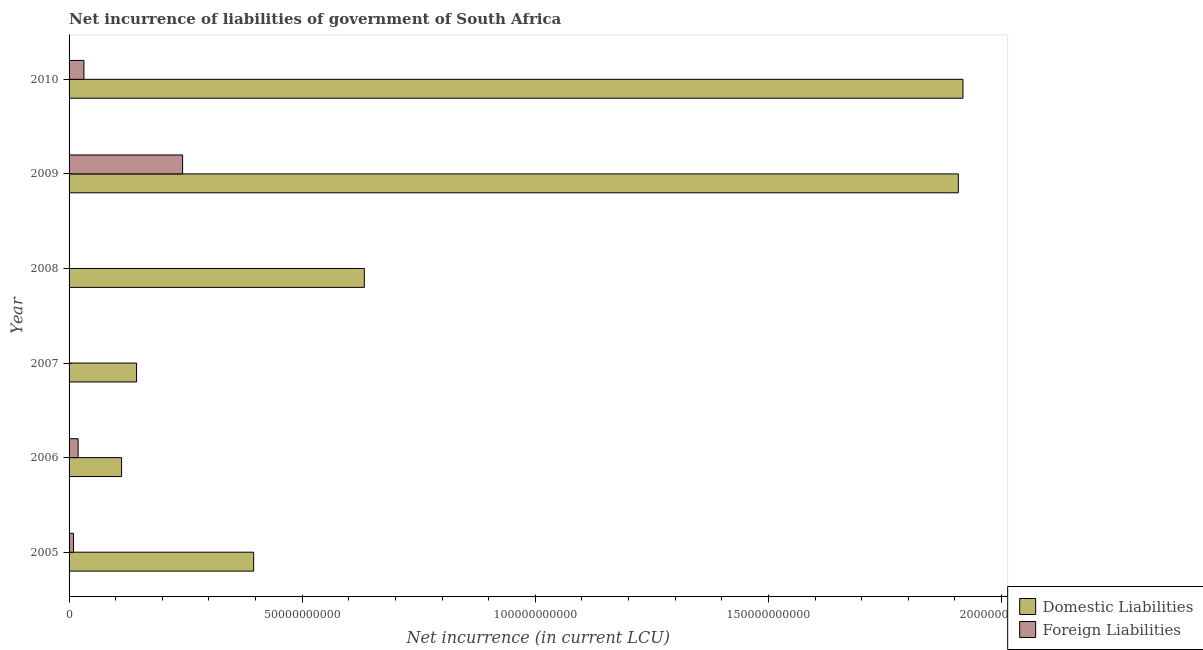How many different coloured bars are there?
Keep it short and to the point. 2. Are the number of bars per tick equal to the number of legend labels?
Your answer should be compact. No. Are the number of bars on each tick of the Y-axis equal?
Give a very brief answer. No. What is the label of the 4th group of bars from the top?
Your answer should be very brief. 2007. In how many cases, is the number of bars for a given year not equal to the number of legend labels?
Make the answer very short. 2. What is the net incurrence of foreign liabilities in 2006?
Make the answer very short. 1.94e+09. Across all years, what is the maximum net incurrence of domestic liabilities?
Make the answer very short. 1.92e+11. Across all years, what is the minimum net incurrence of domestic liabilities?
Ensure brevity in your answer.  1.13e+1. What is the total net incurrence of domestic liabilities in the graph?
Ensure brevity in your answer.  5.11e+11. What is the difference between the net incurrence of domestic liabilities in 2006 and that in 2007?
Your response must be concise. -3.21e+09. What is the difference between the net incurrence of foreign liabilities in 2009 and the net incurrence of domestic liabilities in 2010?
Ensure brevity in your answer.  -1.67e+11. What is the average net incurrence of foreign liabilities per year?
Offer a terse response. 5.07e+09. In the year 2009, what is the difference between the net incurrence of foreign liabilities and net incurrence of domestic liabilities?
Provide a short and direct response. -1.66e+11. In how many years, is the net incurrence of domestic liabilities greater than 10000000000 LCU?
Provide a succinct answer. 6. What is the ratio of the net incurrence of foreign liabilities in 2005 to that in 2010?
Keep it short and to the point. 0.3. Is the net incurrence of foreign liabilities in 2005 less than that in 2010?
Offer a terse response. Yes. Is the difference between the net incurrence of foreign liabilities in 2005 and 2006 greater than the difference between the net incurrence of domestic liabilities in 2005 and 2006?
Your response must be concise. No. What is the difference between the highest and the second highest net incurrence of foreign liabilities?
Your answer should be compact. 2.12e+1. What is the difference between the highest and the lowest net incurrence of foreign liabilities?
Keep it short and to the point. 2.44e+1. How many bars are there?
Offer a very short reply. 10. Are all the bars in the graph horizontal?
Make the answer very short. Yes. What is the difference between two consecutive major ticks on the X-axis?
Your response must be concise. 5.00e+1. Does the graph contain grids?
Offer a very short reply. No. How many legend labels are there?
Offer a very short reply. 2. What is the title of the graph?
Ensure brevity in your answer.  Net incurrence of liabilities of government of South Africa. Does "Infant" appear as one of the legend labels in the graph?
Your answer should be very brief. No. What is the label or title of the X-axis?
Offer a terse response. Net incurrence (in current LCU). What is the label or title of the Y-axis?
Your response must be concise. Year. What is the Net incurrence (in current LCU) in Domestic Liabilities in 2005?
Keep it short and to the point. 3.96e+1. What is the Net incurrence (in current LCU) of Foreign Liabilities in 2005?
Offer a very short reply. 9.50e+08. What is the Net incurrence (in current LCU) of Domestic Liabilities in 2006?
Give a very brief answer. 1.13e+1. What is the Net incurrence (in current LCU) in Foreign Liabilities in 2006?
Make the answer very short. 1.94e+09. What is the Net incurrence (in current LCU) of Domestic Liabilities in 2007?
Ensure brevity in your answer.  1.45e+1. What is the Net incurrence (in current LCU) of Foreign Liabilities in 2007?
Offer a terse response. 0. What is the Net incurrence (in current LCU) in Domestic Liabilities in 2008?
Provide a succinct answer. 6.33e+1. What is the Net incurrence (in current LCU) of Domestic Liabilities in 2009?
Ensure brevity in your answer.  1.91e+11. What is the Net incurrence (in current LCU) of Foreign Liabilities in 2009?
Offer a very short reply. 2.44e+1. What is the Net incurrence (in current LCU) in Domestic Liabilities in 2010?
Provide a short and direct response. 1.92e+11. What is the Net incurrence (in current LCU) in Foreign Liabilities in 2010?
Offer a very short reply. 3.18e+09. Across all years, what is the maximum Net incurrence (in current LCU) in Domestic Liabilities?
Your response must be concise. 1.92e+11. Across all years, what is the maximum Net incurrence (in current LCU) in Foreign Liabilities?
Offer a terse response. 2.44e+1. Across all years, what is the minimum Net incurrence (in current LCU) in Domestic Liabilities?
Make the answer very short. 1.13e+1. Across all years, what is the minimum Net incurrence (in current LCU) in Foreign Liabilities?
Keep it short and to the point. 0. What is the total Net incurrence (in current LCU) of Domestic Liabilities in the graph?
Your response must be concise. 5.11e+11. What is the total Net incurrence (in current LCU) of Foreign Liabilities in the graph?
Offer a terse response. 3.04e+1. What is the difference between the Net incurrence (in current LCU) of Domestic Liabilities in 2005 and that in 2006?
Your answer should be compact. 2.83e+1. What is the difference between the Net incurrence (in current LCU) of Foreign Liabilities in 2005 and that in 2006?
Offer a very short reply. -9.93e+08. What is the difference between the Net incurrence (in current LCU) in Domestic Liabilities in 2005 and that in 2007?
Your answer should be compact. 2.51e+1. What is the difference between the Net incurrence (in current LCU) of Domestic Liabilities in 2005 and that in 2008?
Make the answer very short. -2.37e+1. What is the difference between the Net incurrence (in current LCU) of Domestic Liabilities in 2005 and that in 2009?
Ensure brevity in your answer.  -1.51e+11. What is the difference between the Net incurrence (in current LCU) in Foreign Liabilities in 2005 and that in 2009?
Your response must be concise. -2.34e+1. What is the difference between the Net incurrence (in current LCU) of Domestic Liabilities in 2005 and that in 2010?
Your answer should be compact. -1.52e+11. What is the difference between the Net incurrence (in current LCU) in Foreign Liabilities in 2005 and that in 2010?
Offer a very short reply. -2.23e+09. What is the difference between the Net incurrence (in current LCU) of Domestic Liabilities in 2006 and that in 2007?
Offer a terse response. -3.21e+09. What is the difference between the Net incurrence (in current LCU) in Domestic Liabilities in 2006 and that in 2008?
Provide a succinct answer. -5.21e+1. What is the difference between the Net incurrence (in current LCU) of Domestic Liabilities in 2006 and that in 2009?
Ensure brevity in your answer.  -1.79e+11. What is the difference between the Net incurrence (in current LCU) of Foreign Liabilities in 2006 and that in 2009?
Your answer should be very brief. -2.24e+1. What is the difference between the Net incurrence (in current LCU) in Domestic Liabilities in 2006 and that in 2010?
Give a very brief answer. -1.80e+11. What is the difference between the Net incurrence (in current LCU) in Foreign Liabilities in 2006 and that in 2010?
Make the answer very short. -1.24e+09. What is the difference between the Net incurrence (in current LCU) in Domestic Liabilities in 2007 and that in 2008?
Provide a succinct answer. -4.89e+1. What is the difference between the Net incurrence (in current LCU) in Domestic Liabilities in 2007 and that in 2009?
Make the answer very short. -1.76e+11. What is the difference between the Net incurrence (in current LCU) in Domestic Liabilities in 2007 and that in 2010?
Your answer should be compact. -1.77e+11. What is the difference between the Net incurrence (in current LCU) of Domestic Liabilities in 2008 and that in 2009?
Make the answer very short. -1.27e+11. What is the difference between the Net incurrence (in current LCU) of Domestic Liabilities in 2008 and that in 2010?
Your answer should be compact. -1.28e+11. What is the difference between the Net incurrence (in current LCU) of Domestic Liabilities in 2009 and that in 2010?
Your response must be concise. -9.92e+08. What is the difference between the Net incurrence (in current LCU) of Foreign Liabilities in 2009 and that in 2010?
Ensure brevity in your answer.  2.12e+1. What is the difference between the Net incurrence (in current LCU) in Domestic Liabilities in 2005 and the Net incurrence (in current LCU) in Foreign Liabilities in 2006?
Offer a very short reply. 3.76e+1. What is the difference between the Net incurrence (in current LCU) of Domestic Liabilities in 2005 and the Net incurrence (in current LCU) of Foreign Liabilities in 2009?
Your answer should be compact. 1.52e+1. What is the difference between the Net incurrence (in current LCU) of Domestic Liabilities in 2005 and the Net incurrence (in current LCU) of Foreign Liabilities in 2010?
Your answer should be very brief. 3.64e+1. What is the difference between the Net incurrence (in current LCU) in Domestic Liabilities in 2006 and the Net incurrence (in current LCU) in Foreign Liabilities in 2009?
Keep it short and to the point. -1.31e+1. What is the difference between the Net incurrence (in current LCU) in Domestic Liabilities in 2006 and the Net incurrence (in current LCU) in Foreign Liabilities in 2010?
Ensure brevity in your answer.  8.08e+09. What is the difference between the Net incurrence (in current LCU) of Domestic Liabilities in 2007 and the Net incurrence (in current LCU) of Foreign Liabilities in 2009?
Ensure brevity in your answer.  -9.88e+09. What is the difference between the Net incurrence (in current LCU) in Domestic Liabilities in 2007 and the Net incurrence (in current LCU) in Foreign Liabilities in 2010?
Offer a terse response. 1.13e+1. What is the difference between the Net incurrence (in current LCU) of Domestic Liabilities in 2008 and the Net incurrence (in current LCU) of Foreign Liabilities in 2009?
Your response must be concise. 3.90e+1. What is the difference between the Net incurrence (in current LCU) of Domestic Liabilities in 2008 and the Net incurrence (in current LCU) of Foreign Liabilities in 2010?
Your answer should be compact. 6.01e+1. What is the difference between the Net incurrence (in current LCU) of Domestic Liabilities in 2009 and the Net incurrence (in current LCU) of Foreign Liabilities in 2010?
Make the answer very short. 1.88e+11. What is the average Net incurrence (in current LCU) of Domestic Liabilities per year?
Your answer should be compact. 8.52e+1. What is the average Net incurrence (in current LCU) in Foreign Liabilities per year?
Your response must be concise. 5.07e+09. In the year 2005, what is the difference between the Net incurrence (in current LCU) in Domestic Liabilities and Net incurrence (in current LCU) in Foreign Liabilities?
Offer a very short reply. 3.86e+1. In the year 2006, what is the difference between the Net incurrence (in current LCU) of Domestic Liabilities and Net incurrence (in current LCU) of Foreign Liabilities?
Keep it short and to the point. 9.32e+09. In the year 2009, what is the difference between the Net incurrence (in current LCU) in Domestic Liabilities and Net incurrence (in current LCU) in Foreign Liabilities?
Offer a very short reply. 1.66e+11. In the year 2010, what is the difference between the Net incurrence (in current LCU) of Domestic Liabilities and Net incurrence (in current LCU) of Foreign Liabilities?
Your answer should be very brief. 1.89e+11. What is the ratio of the Net incurrence (in current LCU) of Domestic Liabilities in 2005 to that in 2006?
Your response must be concise. 3.52. What is the ratio of the Net incurrence (in current LCU) in Foreign Liabilities in 2005 to that in 2006?
Your response must be concise. 0.49. What is the ratio of the Net incurrence (in current LCU) of Domestic Liabilities in 2005 to that in 2007?
Provide a succinct answer. 2.73. What is the ratio of the Net incurrence (in current LCU) of Domestic Liabilities in 2005 to that in 2008?
Your response must be concise. 0.63. What is the ratio of the Net incurrence (in current LCU) of Domestic Liabilities in 2005 to that in 2009?
Offer a terse response. 0.21. What is the ratio of the Net incurrence (in current LCU) of Foreign Liabilities in 2005 to that in 2009?
Ensure brevity in your answer.  0.04. What is the ratio of the Net incurrence (in current LCU) in Domestic Liabilities in 2005 to that in 2010?
Keep it short and to the point. 0.21. What is the ratio of the Net incurrence (in current LCU) in Foreign Liabilities in 2005 to that in 2010?
Ensure brevity in your answer.  0.3. What is the ratio of the Net incurrence (in current LCU) of Domestic Liabilities in 2006 to that in 2007?
Ensure brevity in your answer.  0.78. What is the ratio of the Net incurrence (in current LCU) of Domestic Liabilities in 2006 to that in 2008?
Provide a short and direct response. 0.18. What is the ratio of the Net incurrence (in current LCU) in Domestic Liabilities in 2006 to that in 2009?
Offer a very short reply. 0.06. What is the ratio of the Net incurrence (in current LCU) of Foreign Liabilities in 2006 to that in 2009?
Your response must be concise. 0.08. What is the ratio of the Net incurrence (in current LCU) of Domestic Liabilities in 2006 to that in 2010?
Make the answer very short. 0.06. What is the ratio of the Net incurrence (in current LCU) in Foreign Liabilities in 2006 to that in 2010?
Offer a terse response. 0.61. What is the ratio of the Net incurrence (in current LCU) of Domestic Liabilities in 2007 to that in 2008?
Offer a very short reply. 0.23. What is the ratio of the Net incurrence (in current LCU) of Domestic Liabilities in 2007 to that in 2009?
Your answer should be compact. 0.08. What is the ratio of the Net incurrence (in current LCU) of Domestic Liabilities in 2007 to that in 2010?
Make the answer very short. 0.08. What is the ratio of the Net incurrence (in current LCU) of Domestic Liabilities in 2008 to that in 2009?
Your answer should be compact. 0.33. What is the ratio of the Net incurrence (in current LCU) of Domestic Liabilities in 2008 to that in 2010?
Provide a succinct answer. 0.33. What is the ratio of the Net incurrence (in current LCU) in Foreign Liabilities in 2009 to that in 2010?
Offer a very short reply. 7.65. What is the difference between the highest and the second highest Net incurrence (in current LCU) in Domestic Liabilities?
Offer a terse response. 9.92e+08. What is the difference between the highest and the second highest Net incurrence (in current LCU) of Foreign Liabilities?
Provide a short and direct response. 2.12e+1. What is the difference between the highest and the lowest Net incurrence (in current LCU) of Domestic Liabilities?
Ensure brevity in your answer.  1.80e+11. What is the difference between the highest and the lowest Net incurrence (in current LCU) in Foreign Liabilities?
Give a very brief answer. 2.44e+1. 